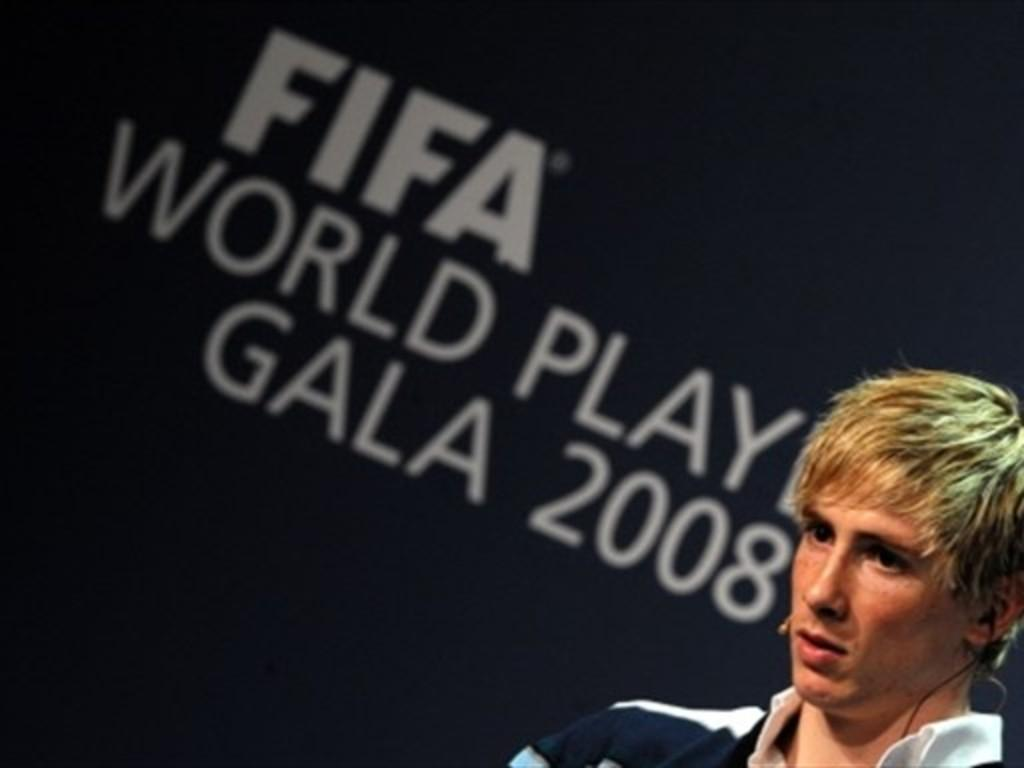Who or what is the main subject in the image? There is a person in the image. What can be seen in the background of the image? There is a wall or a board in the background of the image. What is written or displayed on the wall or board? The wall or board has words and numbers on it. Can you tell me how many ducks are swimming in the scene depicted on the wall or board? There is no scene with ducks present on the wall or board; it only has words and numbers on it. 